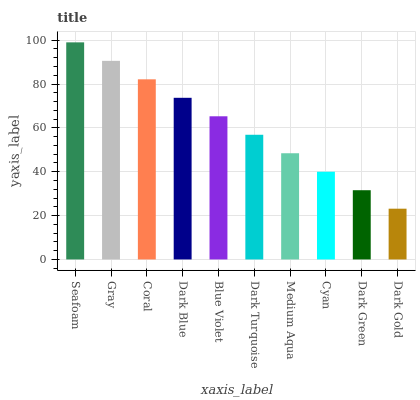Is Dark Gold the minimum?
Answer yes or no. Yes. Is Seafoam the maximum?
Answer yes or no. Yes. Is Gray the minimum?
Answer yes or no. No. Is Gray the maximum?
Answer yes or no. No. Is Seafoam greater than Gray?
Answer yes or no. Yes. Is Gray less than Seafoam?
Answer yes or no. Yes. Is Gray greater than Seafoam?
Answer yes or no. No. Is Seafoam less than Gray?
Answer yes or no. No. Is Blue Violet the high median?
Answer yes or no. Yes. Is Dark Turquoise the low median?
Answer yes or no. Yes. Is Dark Blue the high median?
Answer yes or no. No. Is Cyan the low median?
Answer yes or no. No. 